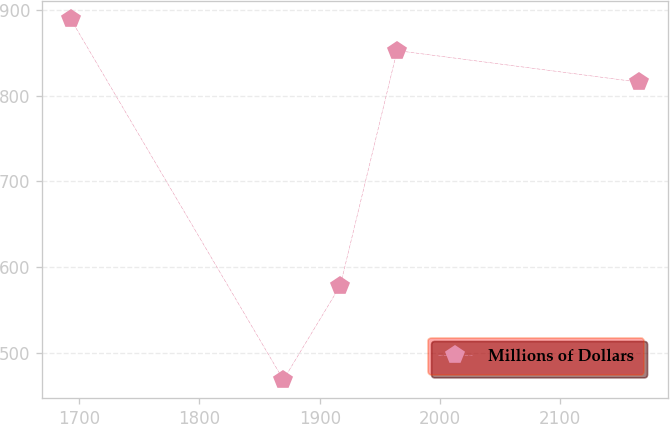Convert chart to OTSL. <chart><loc_0><loc_0><loc_500><loc_500><line_chart><ecel><fcel>Millions of Dollars<nl><fcel>1692.89<fcel>889.5<nl><fcel>1869.8<fcel>468.24<nl><fcel>1917.08<fcel>578.2<nl><fcel>1964.36<fcel>852.65<nl><fcel>2165.65<fcel>815.8<nl></chart> 